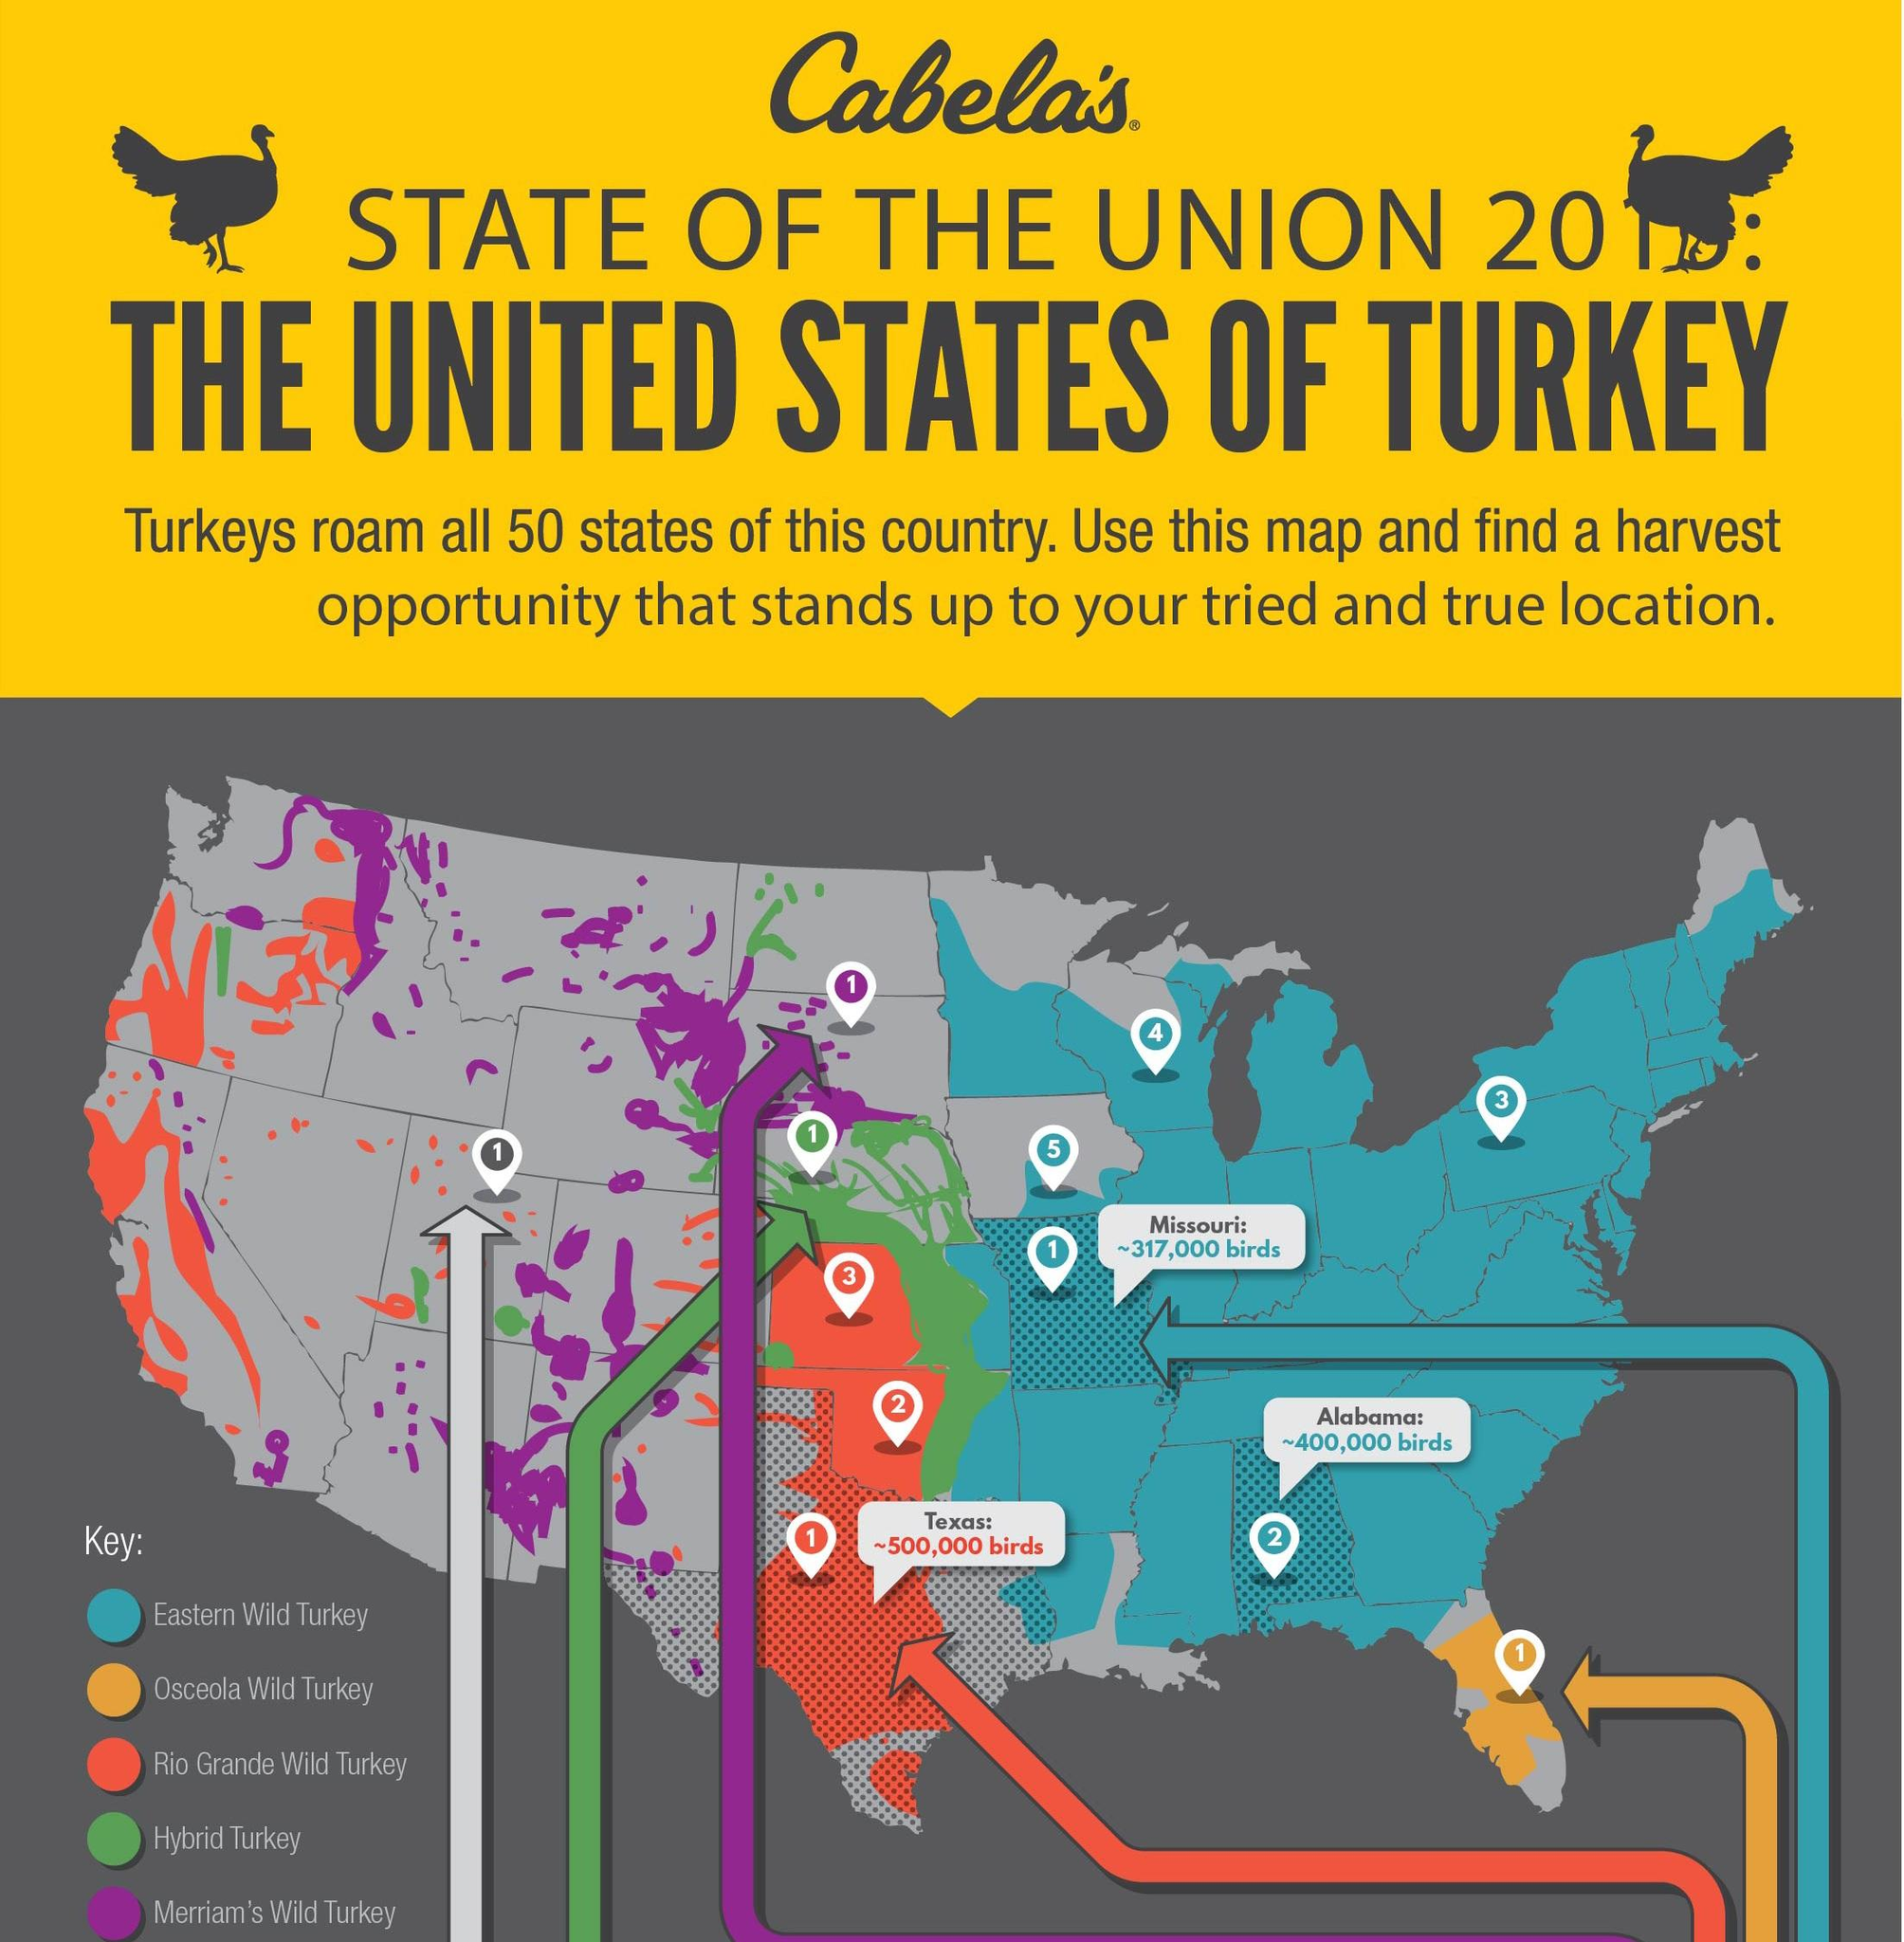Highlight a few significant elements in this photo. Blue covers a significant portion of the map, making it the dominant color. Orange is the color that is commonly used to represent the Osceola Wild Turkey, a specific type of turkey known for its distinct characteristics and behavior. The Rio Grande Wild Turkey is known for its representation of the color red. There are five different types of turkeys mentioned in the key. According to the map, the Eastern Wild Turkey is prevalent in a significant region of the country. 